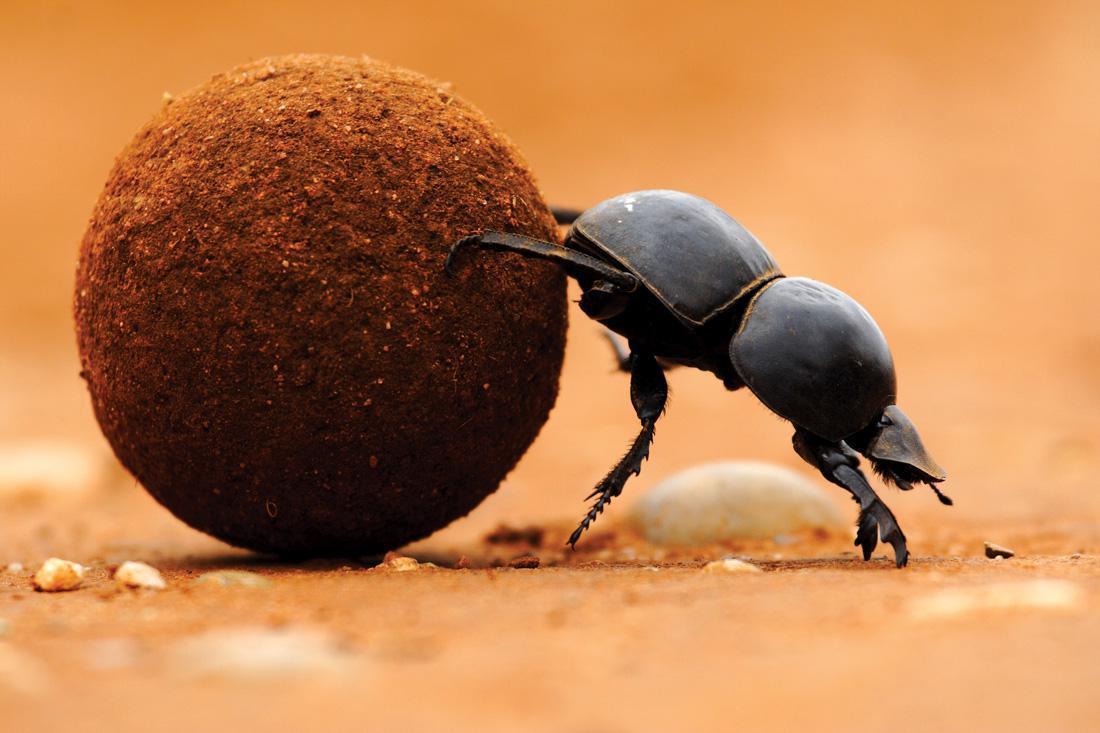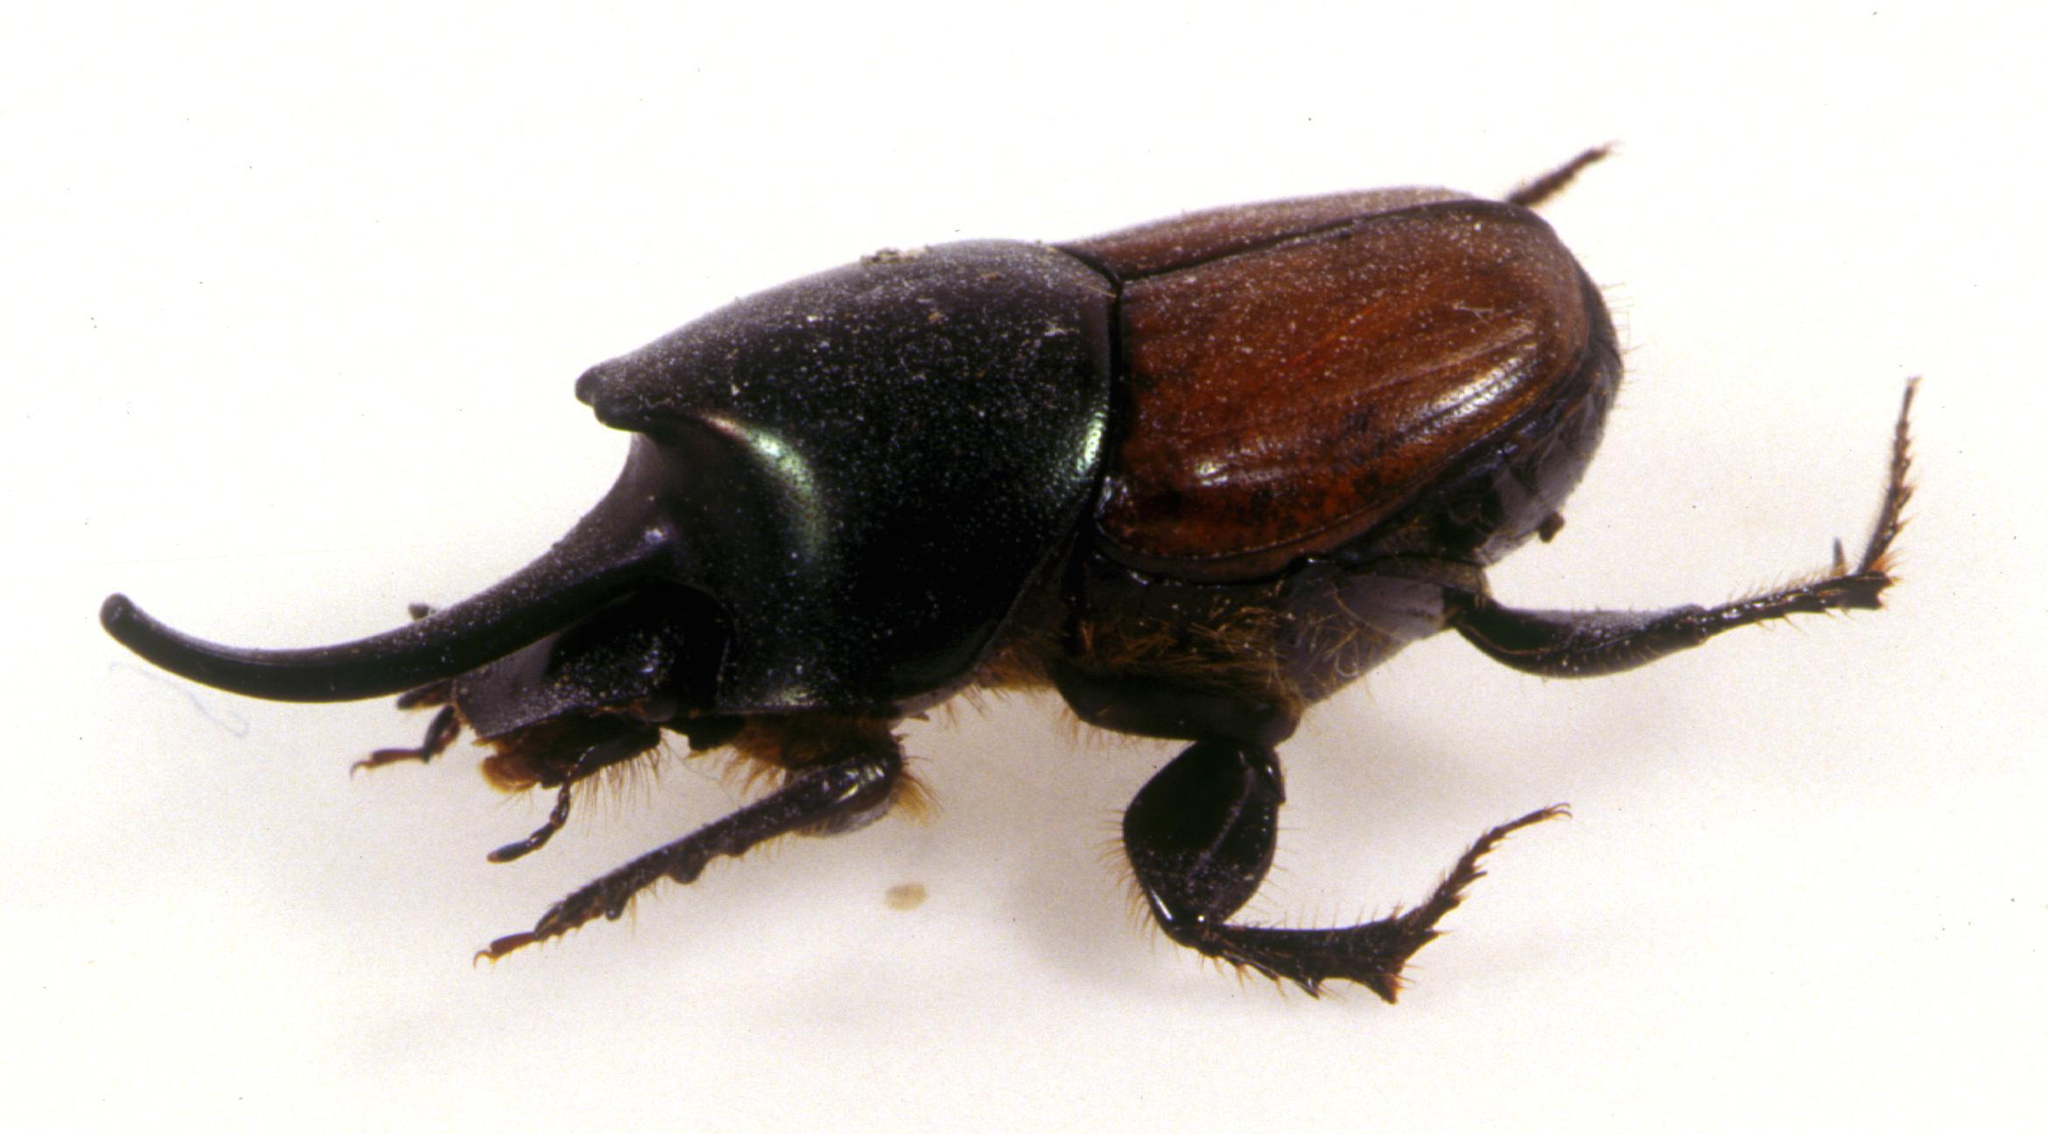The first image is the image on the left, the second image is the image on the right. For the images shown, is this caption "Left image shows just one beetle, with hind legs on dung ball and front legs on ground." true? Answer yes or no. Yes. The first image is the image on the left, the second image is the image on the right. For the images displayed, is the sentence "Two beetles are near a ball of dirt in one of the images." factually correct? Answer yes or no. No. 